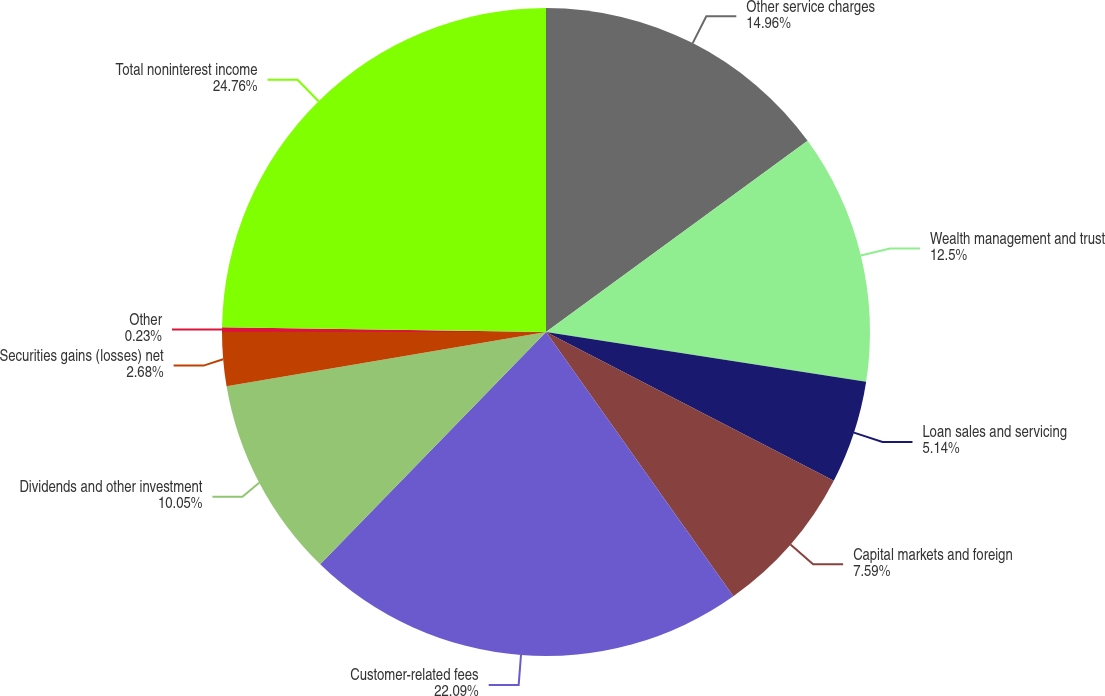<chart> <loc_0><loc_0><loc_500><loc_500><pie_chart><fcel>Other service charges<fcel>Wealth management and trust<fcel>Loan sales and servicing<fcel>Capital markets and foreign<fcel>Customer-related fees<fcel>Dividends and other investment<fcel>Securities gains (losses) net<fcel>Other<fcel>Total noninterest income<nl><fcel>14.96%<fcel>12.5%<fcel>5.14%<fcel>7.59%<fcel>22.09%<fcel>10.05%<fcel>2.68%<fcel>0.23%<fcel>24.77%<nl></chart> 